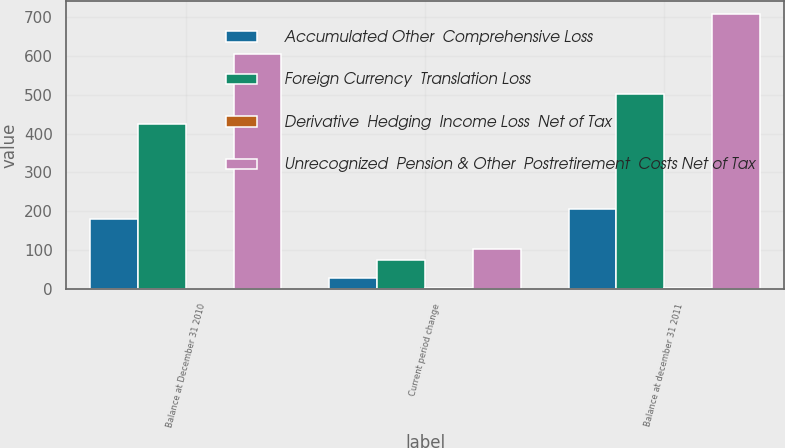<chart> <loc_0><loc_0><loc_500><loc_500><stacked_bar_chart><ecel><fcel>Balance at December 31 2010<fcel>Current period change<fcel>Balance at december 31 2011<nl><fcel>Accumulated Other  Comprehensive Loss<fcel>179.4<fcel>27.7<fcel>207.1<nl><fcel>Foreign Currency  Translation Loss<fcel>425.4<fcel>75.9<fcel>501.3<nl><fcel>Derivative  Hedging  Income Loss  Net of Tax<fcel>0.2<fcel>1.6<fcel>1.4<nl><fcel>Unrecognized  Pension & Other  Postretirement  Costs Net of Tax<fcel>605<fcel>102<fcel>707<nl></chart> 